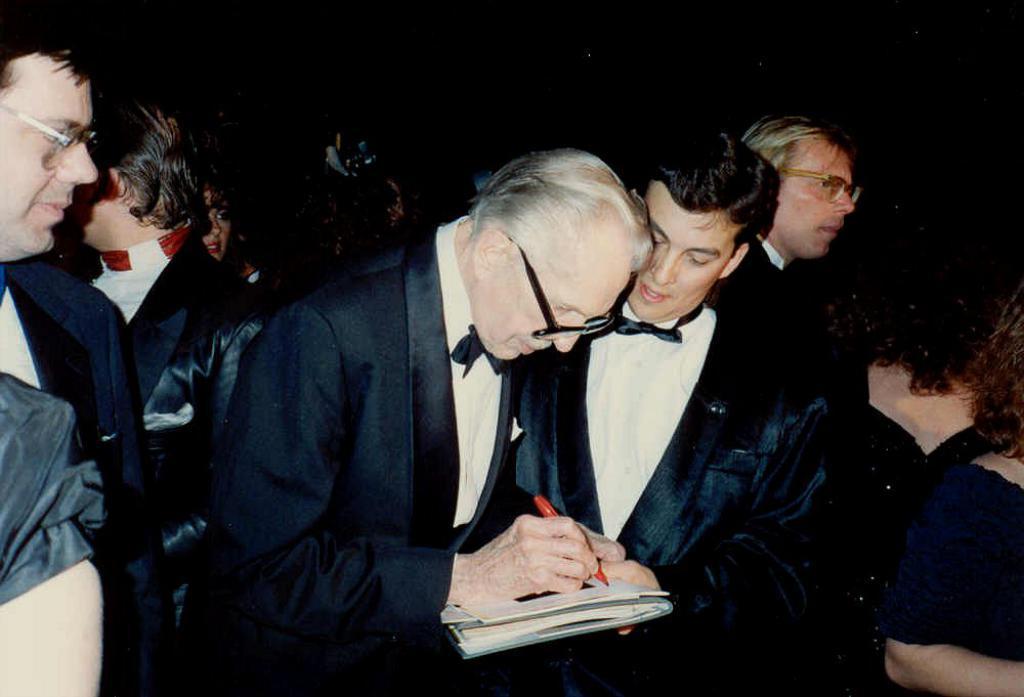How would you summarize this image in a sentence or two? In this image we can see people in the same costume and in the middle we can see a person holding an object. 